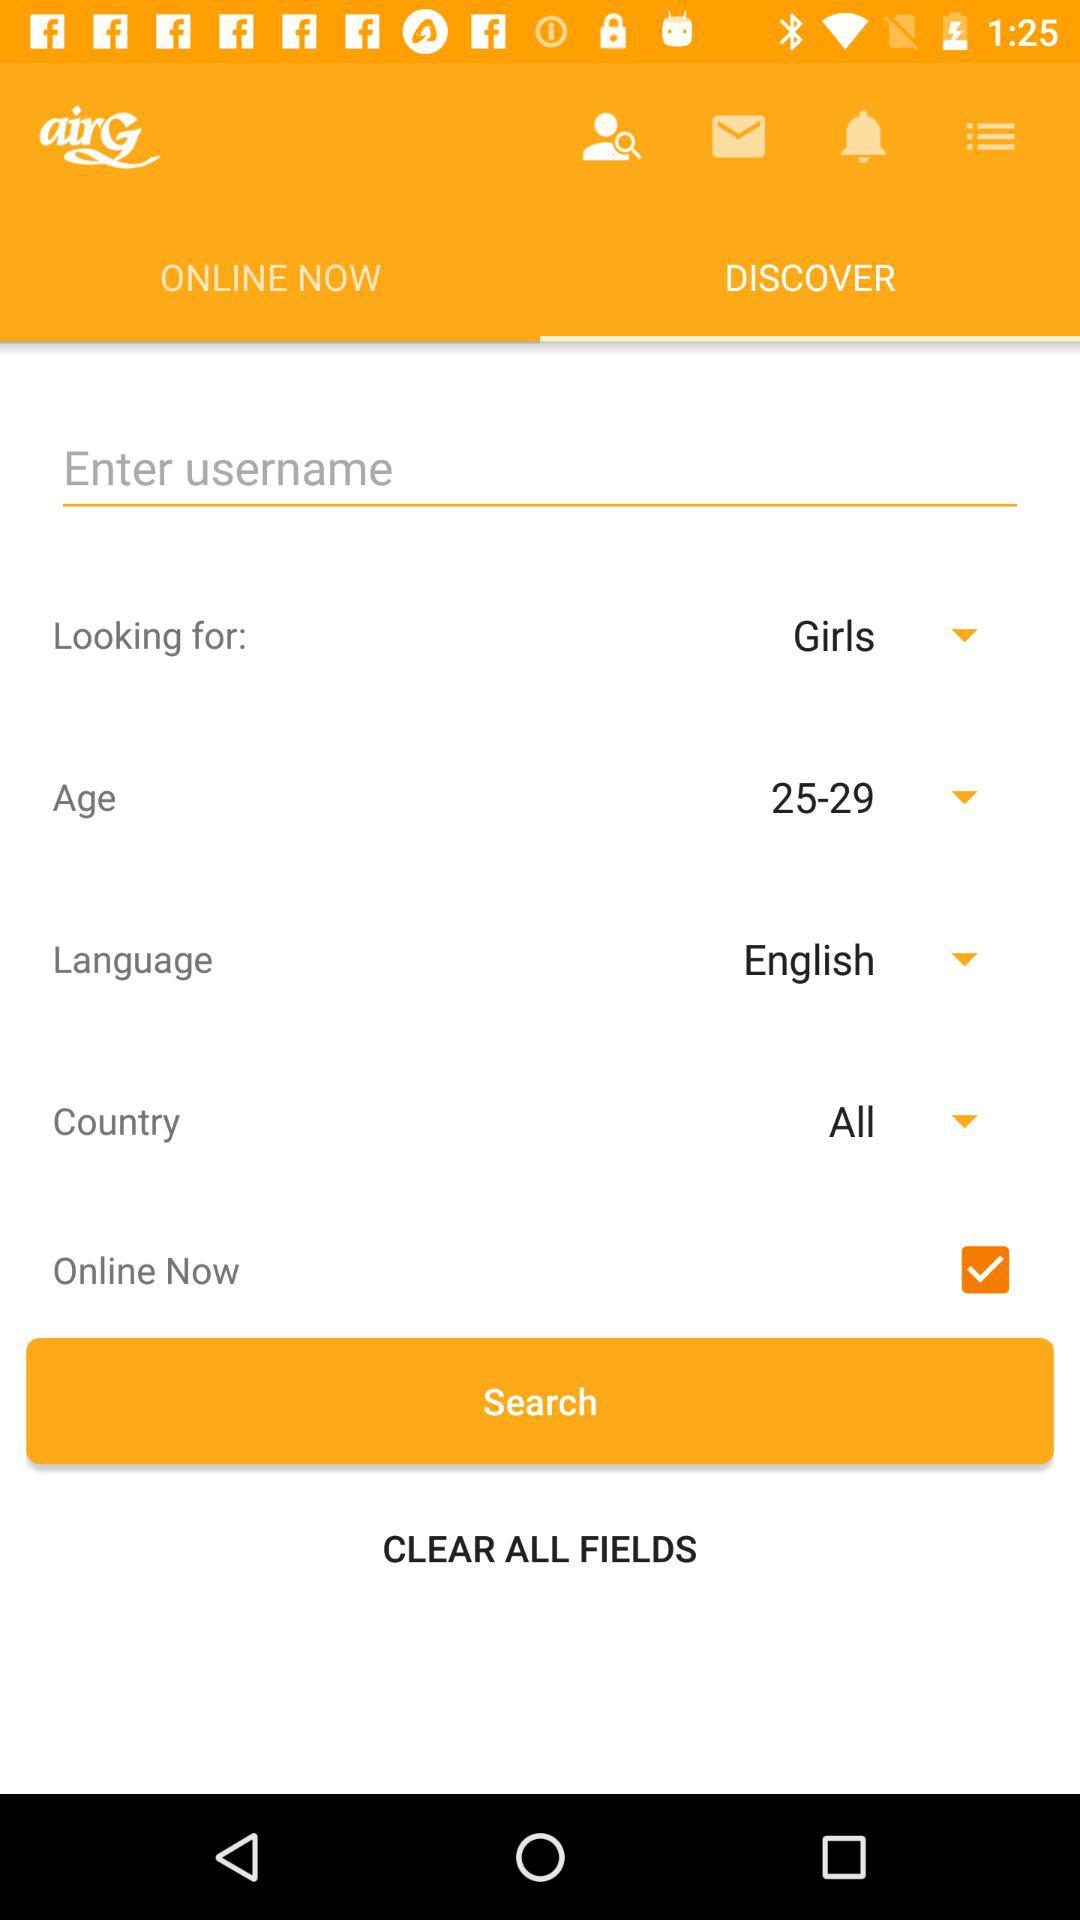What option is selected in "Country"? The selected option is "All". 